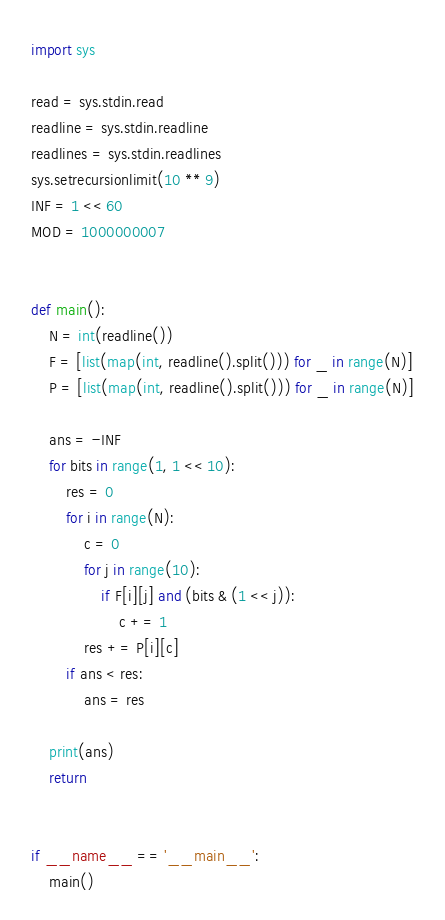<code> <loc_0><loc_0><loc_500><loc_500><_Python_>import sys

read = sys.stdin.read
readline = sys.stdin.readline
readlines = sys.stdin.readlines
sys.setrecursionlimit(10 ** 9)
INF = 1 << 60
MOD = 1000000007


def main():
    N = int(readline())
    F = [list(map(int, readline().split())) for _ in range(N)]
    P = [list(map(int, readline().split())) for _ in range(N)]

    ans = -INF
    for bits in range(1, 1 << 10):
        res = 0
        for i in range(N):
            c = 0
            for j in range(10):
                if F[i][j] and (bits & (1 << j)):
                    c += 1
            res += P[i][c]
        if ans < res:
            ans = res

    print(ans)
    return


if __name__ == '__main__':
    main()
</code> 